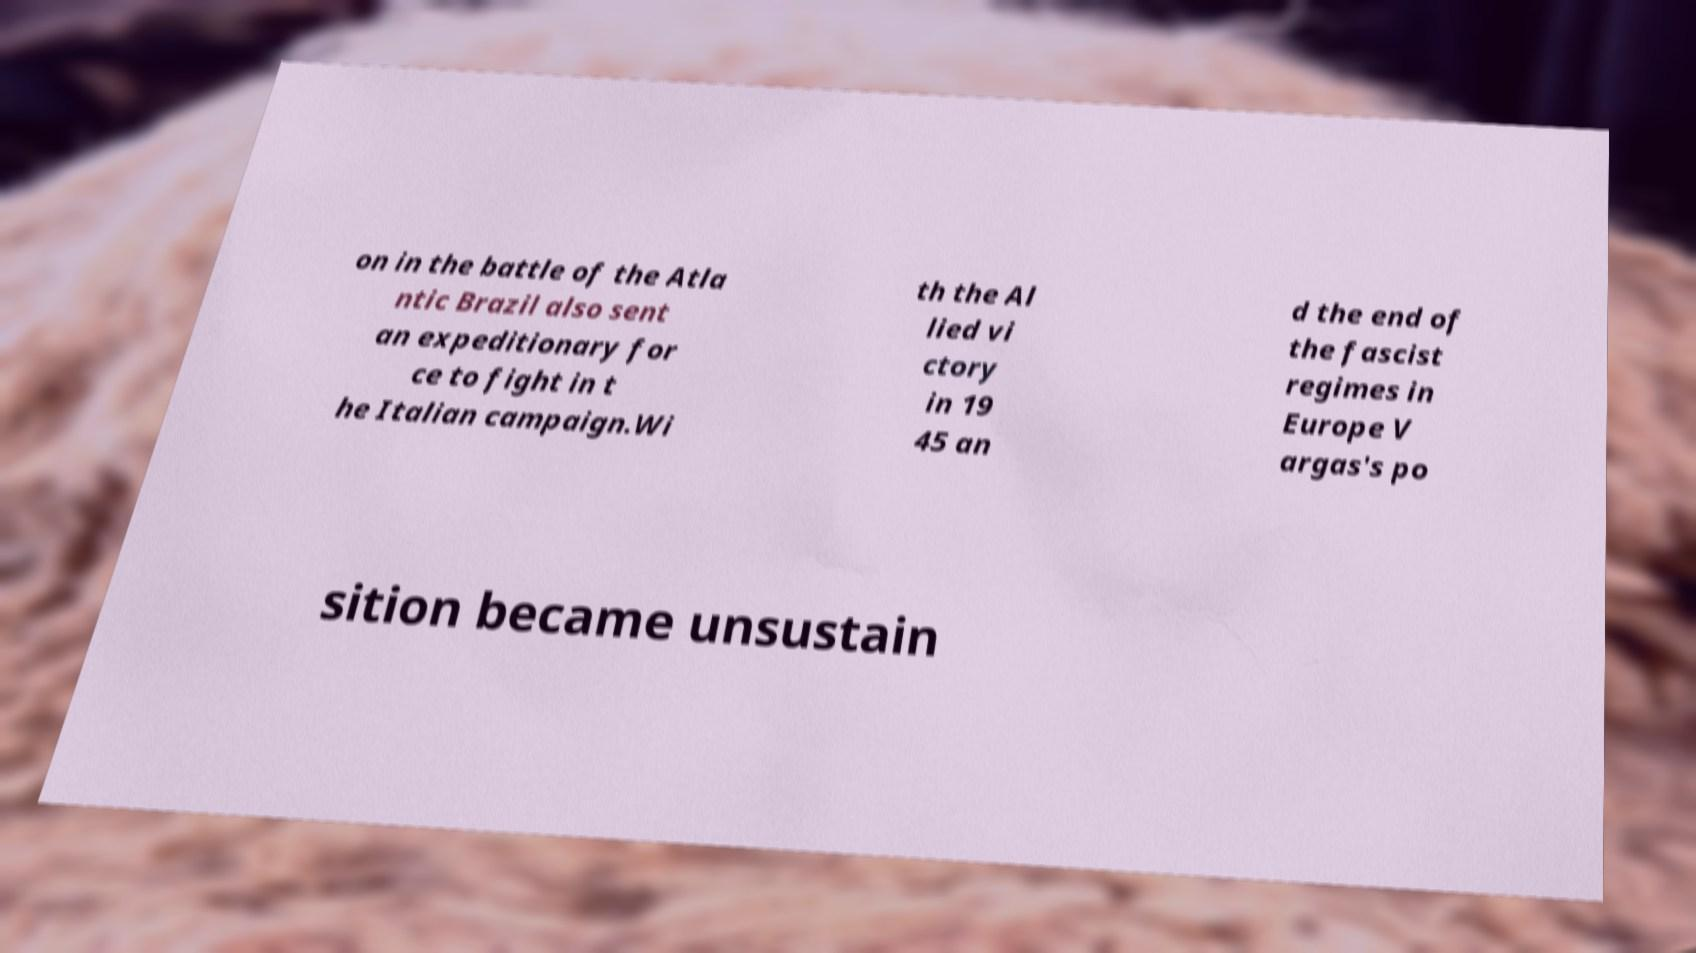I need the written content from this picture converted into text. Can you do that? on in the battle of the Atla ntic Brazil also sent an expeditionary for ce to fight in t he Italian campaign.Wi th the Al lied vi ctory in 19 45 an d the end of the fascist regimes in Europe V argas's po sition became unsustain 